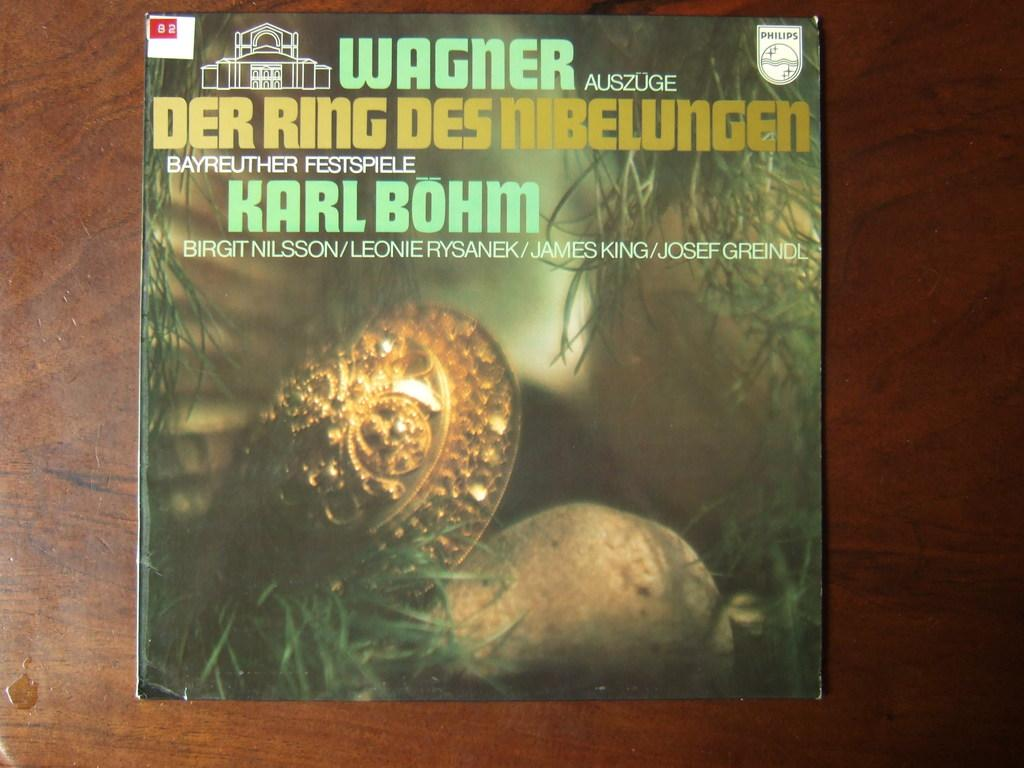<image>
Offer a succinct explanation of the picture presented. A book entitled Wagner Der Ring Des Nibelungen sits on a wooden table. 